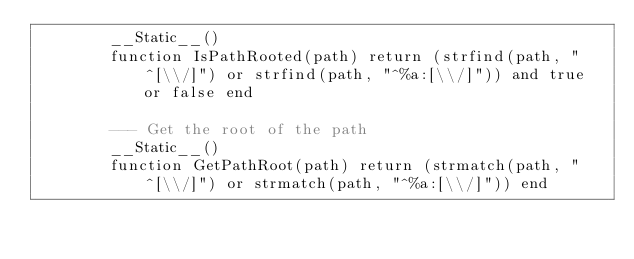<code> <loc_0><loc_0><loc_500><loc_500><_Lua_>        __Static__()
        function IsPathRooted(path) return (strfind(path, "^[\\/]") or strfind(path, "^%a:[\\/]")) and true or false end

        --- Get the root of the path
        __Static__()
        function GetPathRoot(path) return (strmatch(path, "^[\\/]") or strmatch(path, "^%a:[\\/]")) end
</code> 